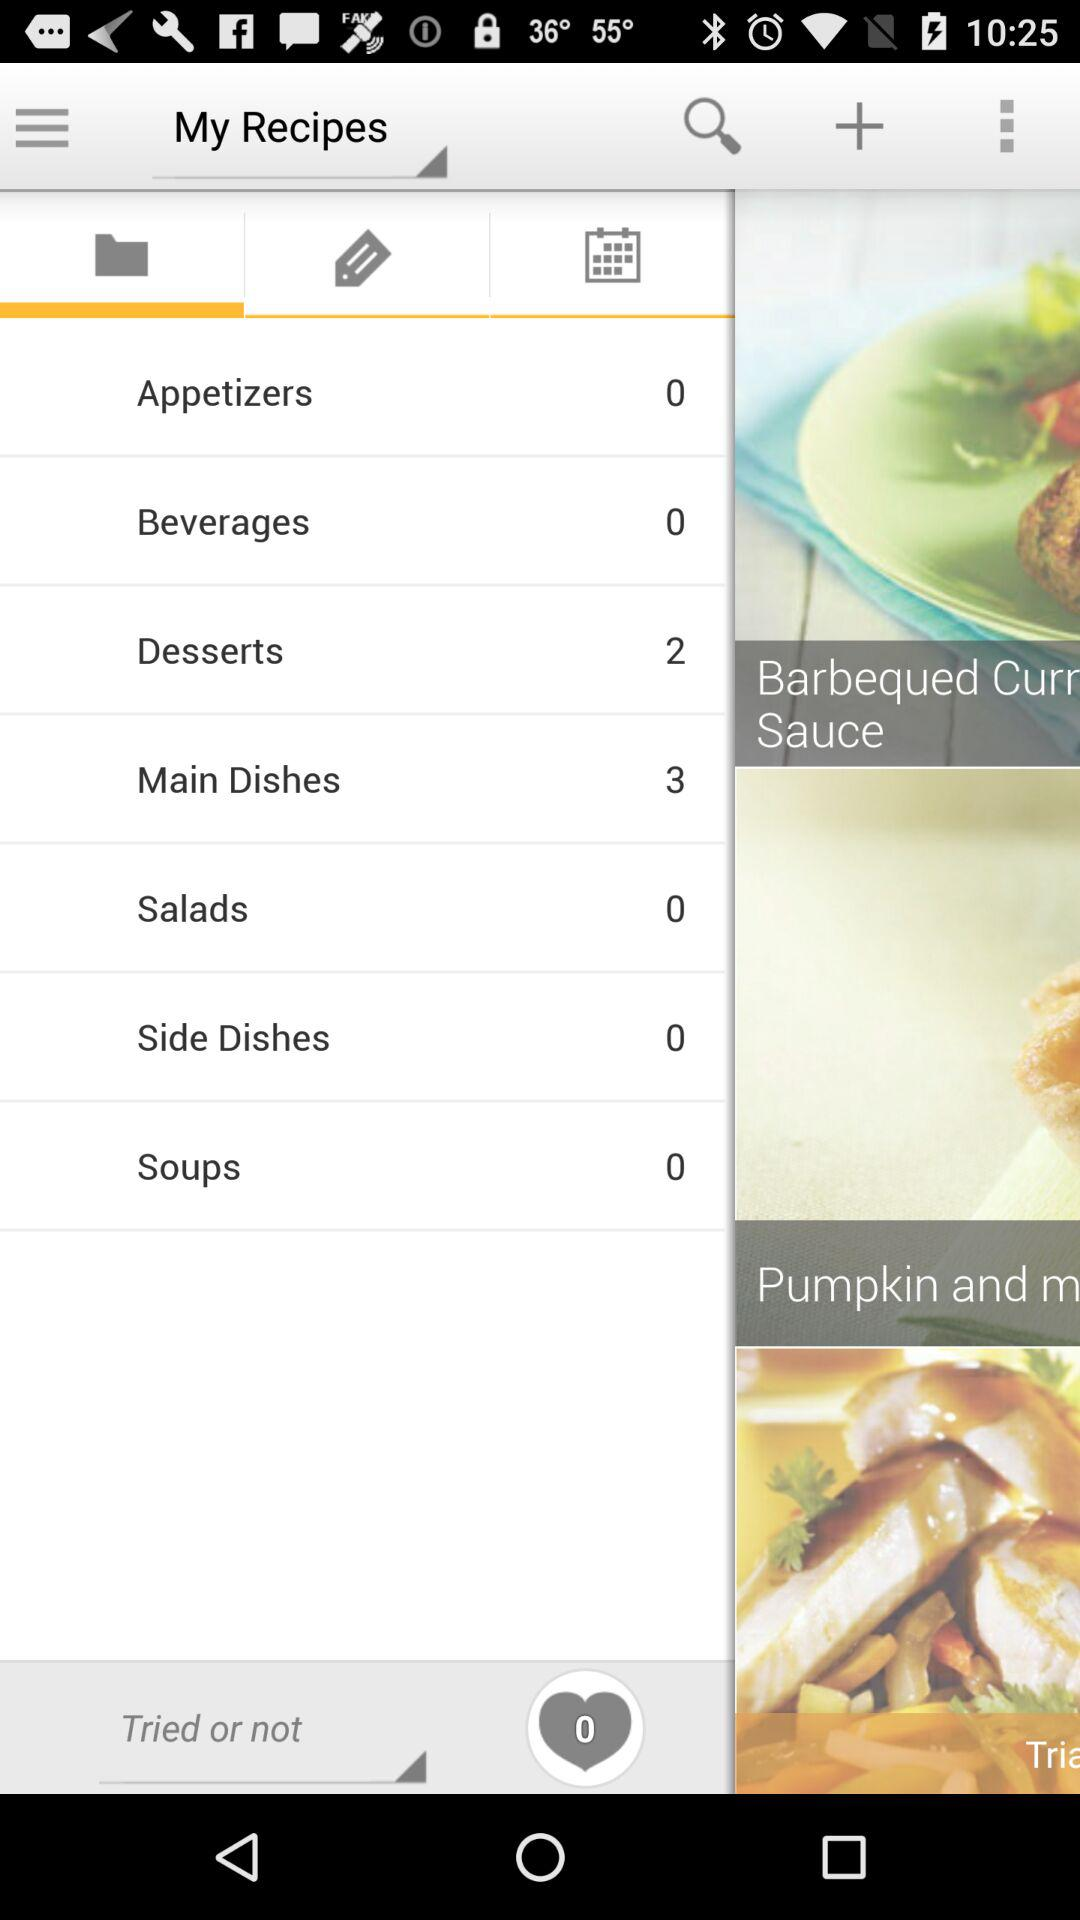What is the folder name?
When the provided information is insufficient, respond with <no answer>. <no answer> 